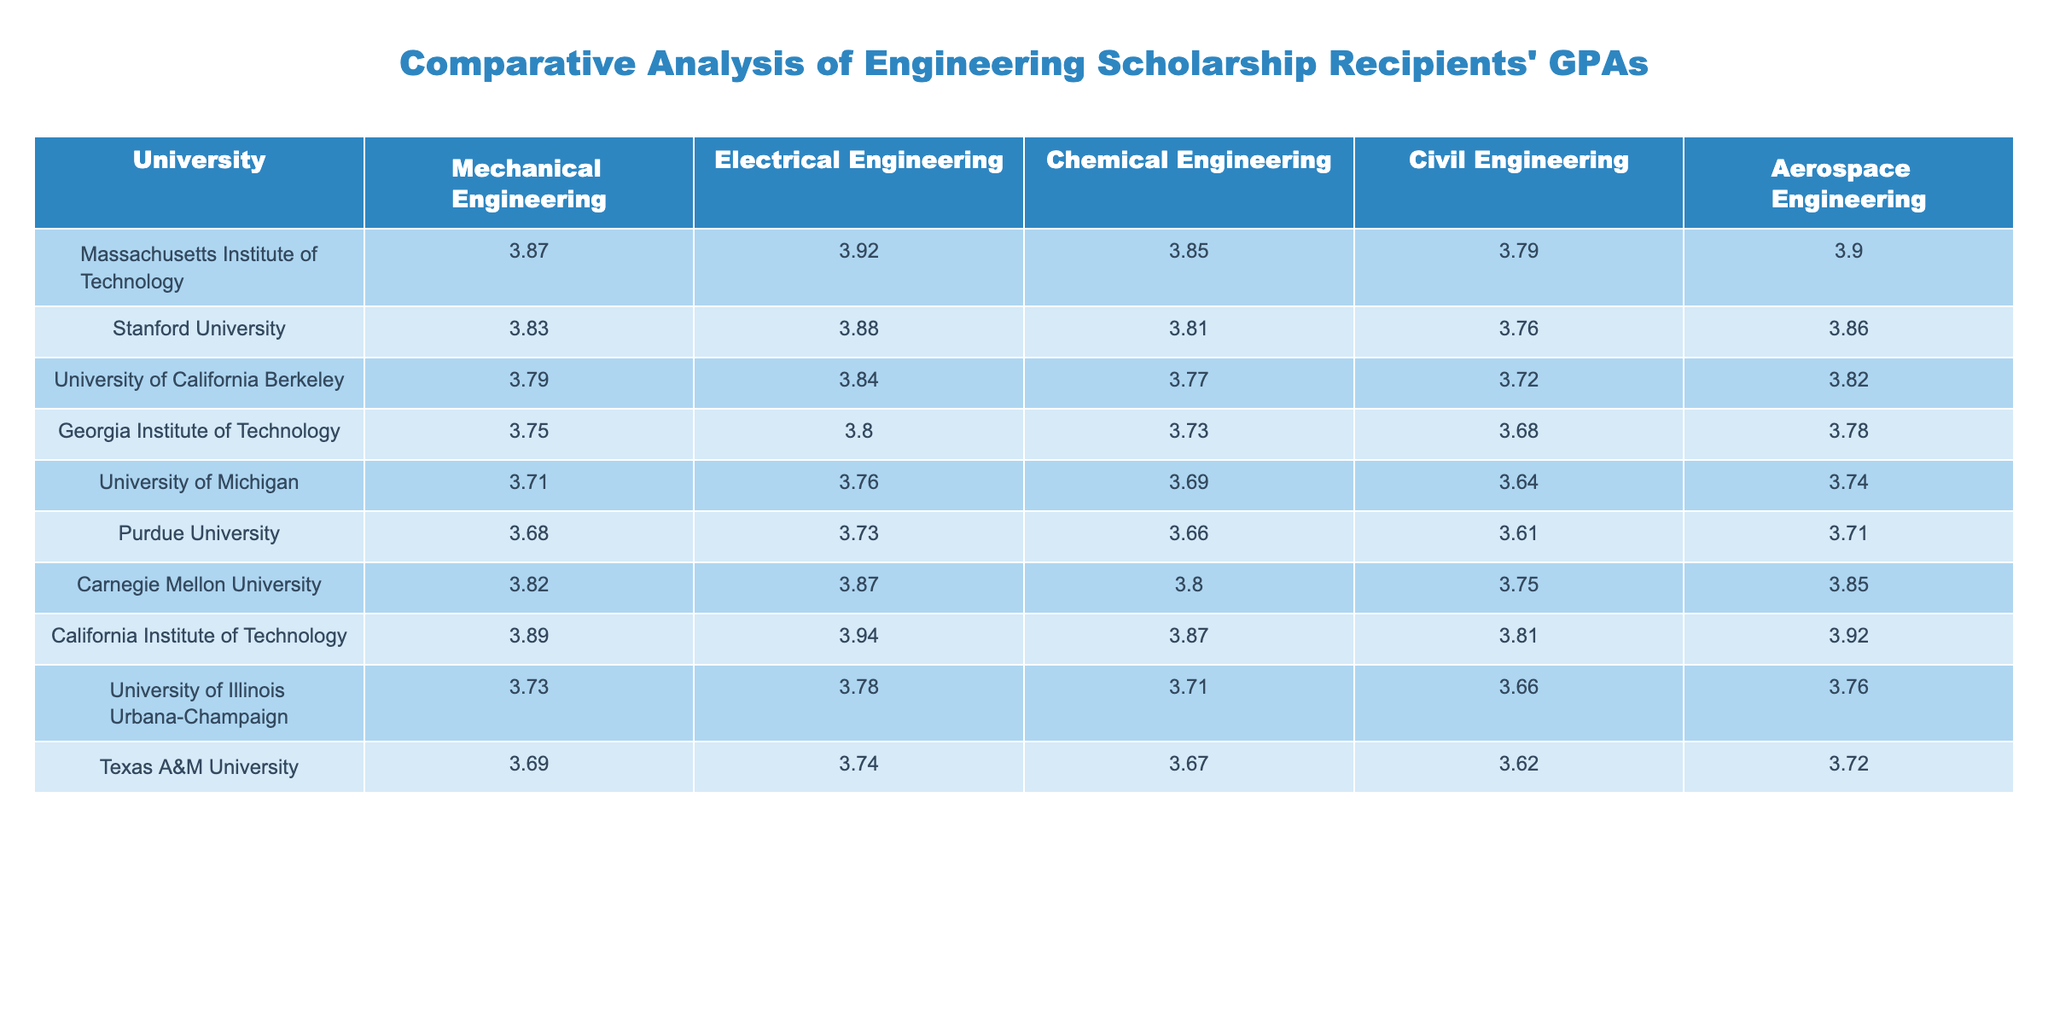What is the GPA of Mechanical Engineering students at Stanford University? The table indicates that the GPA for Mechanical Engineering at Stanford University is 3.83.
Answer: 3.83 Which university has the highest GPA in Civil Engineering? By reviewing the Civil Engineering GPAs in the table, California Institute of Technology has the highest GPA of 3.81.
Answer: California Institute of Technology What is the average GPA for Electrical Engineering across all listed universities? The GPAs for Electrical Engineering are: 3.92, 3.88, 3.84, 3.80, 3.76, 3.73, 3.87, 3.94, 3.78, 3.74. The sum of these values is 37.76, and there are 10 universities: 37.76 / 10 = 3.776.
Answer: 3.776 Is the GPA for Chemical Engineering at Georgia Institute of Technology higher than that at University of Michigan? The GPA for Chemical Engineering at Georgia Institute of Technology is 3.73, while at University of Michigan it is 3.69. Since 3.73 is greater than 3.69, the statement is true.
Answer: Yes What is the difference in GPA for Aerospace Engineering between University of California Berkeley and Purdue University? The GPA for Aerospace Engineering at University of California Berkeley is 3.82 and at Purdue University it is 3.71. The difference is 3.82 - 3.71 = 0.11.
Answer: 0.11 Which engineering discipline shows the largest GPA spread among the listed universities? To determine the spread, the max GPA should be found for each discipline. The maximum GPAs are: Mechanical Engineering 3.89, Electrical Engineering 3.94, Chemical Engineering 3.87, Civil Engineering 3.79, Aerospace Engineering 3.92. The lowest GPAs for these disciplines are 3.68, 3.73, 3.66, 3.61, and 3.71 respectively. The spreads are: 0.21, 0.21, 0.21, 0.18, 0.21. Therefore, all disciplines show the same largest spread of 0.21.
Answer: 0.21 Which university has the lowest GPA in the Civil Engineering category? The table shows that Purdue University has the lowest GPA in Civil Engineering at 3.61.
Answer: Purdue University What are the average GPAs for the top three universities in Mechanical Engineering? The GPAs for the top three universities (Massachusetts Institute of Technology, California Institute of Technology, and Carnegie Mellon University) are 3.87, 3.89, and 3.82, respectively. To find the average, sum these: 3.87 + 3.89 + 3.82 = 11.58, then divide by 3, yielding 11.58 / 3 = 3.86.
Answer: 3.86 Are the average GPAs for Civil Engineering and Aerospace Engineering equal across the universities? The average GPA for Civil Engineering is calculated as (3.79 + 3.76 + 3.72 + 3.68 + 3.64 + 3.61 + 3.75 + 3.81 + 3.66 + 3.62) / 10 = 3.693. The average GPA for Aerospace Engineering is (3.90 + 3.86 + 3.82 + 3.78 + 3.74 + 3.71 + 3.85 + 3.92 + 3.76 + 3.72) / 10 = 3.798. Since these two values are not equal, the answer is no.
Answer: No What is the overall highest GPA among all engineering disciplines in all universities? The highest GPA in the table is 3.94 for Electrical Engineering at California Institute of Technology.
Answer: 3.94 